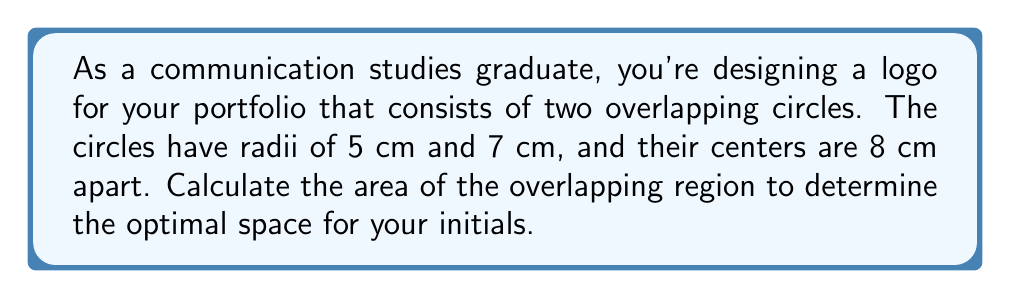Can you solve this math problem? Let's approach this step-by-step:

1) First, we need to find the angle of the sector in each circle that forms the overlapping region. We can do this using the cosine law:

   For the 5 cm circle: $\cos \theta_1 = \frac{5^2 + 8^2 - 7^2}{2 \cdot 5 \cdot 8} = \frac{25 + 64 - 49}{80} = \frac{40}{80} = 0.5$
   
   $\theta_1 = \arccos(0.5) = 1.0472$ radians

   For the 7 cm circle: $\cos \theta_2 = \frac{7^2 + 8^2 - 5^2}{2 \cdot 7 \cdot 8} = \frac{49 + 64 - 25}{112} = \frac{88}{112} = 0.7857$
   
   $\theta_2 = \arccos(0.7857) = 0.6435$ radians

2) Now, we can calculate the areas of the sectors:

   Area of sector in 5 cm circle: $A_1 = \frac{1}{2} \cdot 5^2 \cdot 1.0472 = 13.09$ cm²
   Area of sector in 7 cm circle: $A_2 = \frac{1}{2} \cdot 7^2 \cdot 0.6435 = 15.73$ cm²

3) Next, we need to find the area of the triangles formed by the radii and the line connecting the centers:

   Area of triangle in 5 cm circle: $T_1 = \frac{1}{2} \cdot 5 \cdot 5 \cdot \sin(1.0472) = 10.83$ cm²
   Area of triangle in 7 cm circle: $T_2 = \frac{1}{2} \cdot 7 \cdot 7 \cdot \sin(0.6435) = 14.35$ cm²

4) The area of overlap is the sum of the sectors minus the sum of the triangles:

   Overlap Area = $(A_1 + A_2) - (T_1 + T_2)$
                = $(13.09 + 15.73) - (10.83 + 14.35)$
                = $28.82 - 25.18$
                = $3.64$ cm²

[asy]
unitsize(10mm);
pair O1 = (0,0), O2 = (8,0);
draw(circle(O1,5));
draw(circle(O2,7));
draw(O1--O2);
label("5 cm", O1, SW);
label("7 cm", O2, SE);
label("8 cm", (4,0), S);
[/asy]
Answer: $3.64$ cm² 